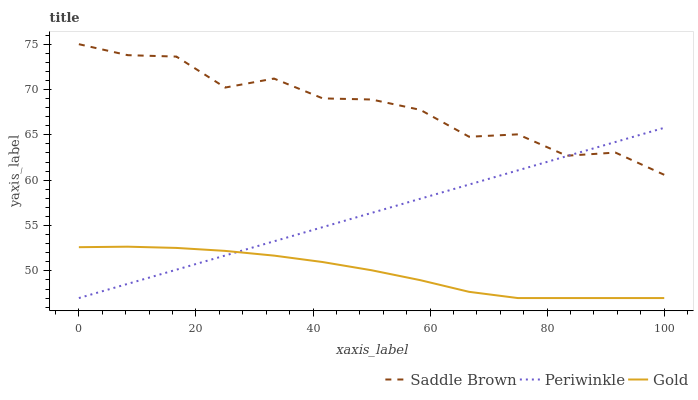Does Gold have the minimum area under the curve?
Answer yes or no. Yes. Does Saddle Brown have the maximum area under the curve?
Answer yes or no. Yes. Does Saddle Brown have the minimum area under the curve?
Answer yes or no. No. Does Gold have the maximum area under the curve?
Answer yes or no. No. Is Periwinkle the smoothest?
Answer yes or no. Yes. Is Saddle Brown the roughest?
Answer yes or no. Yes. Is Gold the smoothest?
Answer yes or no. No. Is Gold the roughest?
Answer yes or no. No. Does Periwinkle have the lowest value?
Answer yes or no. Yes. Does Saddle Brown have the lowest value?
Answer yes or no. No. Does Saddle Brown have the highest value?
Answer yes or no. Yes. Does Gold have the highest value?
Answer yes or no. No. Is Gold less than Saddle Brown?
Answer yes or no. Yes. Is Saddle Brown greater than Gold?
Answer yes or no. Yes. Does Periwinkle intersect Gold?
Answer yes or no. Yes. Is Periwinkle less than Gold?
Answer yes or no. No. Is Periwinkle greater than Gold?
Answer yes or no. No. Does Gold intersect Saddle Brown?
Answer yes or no. No. 